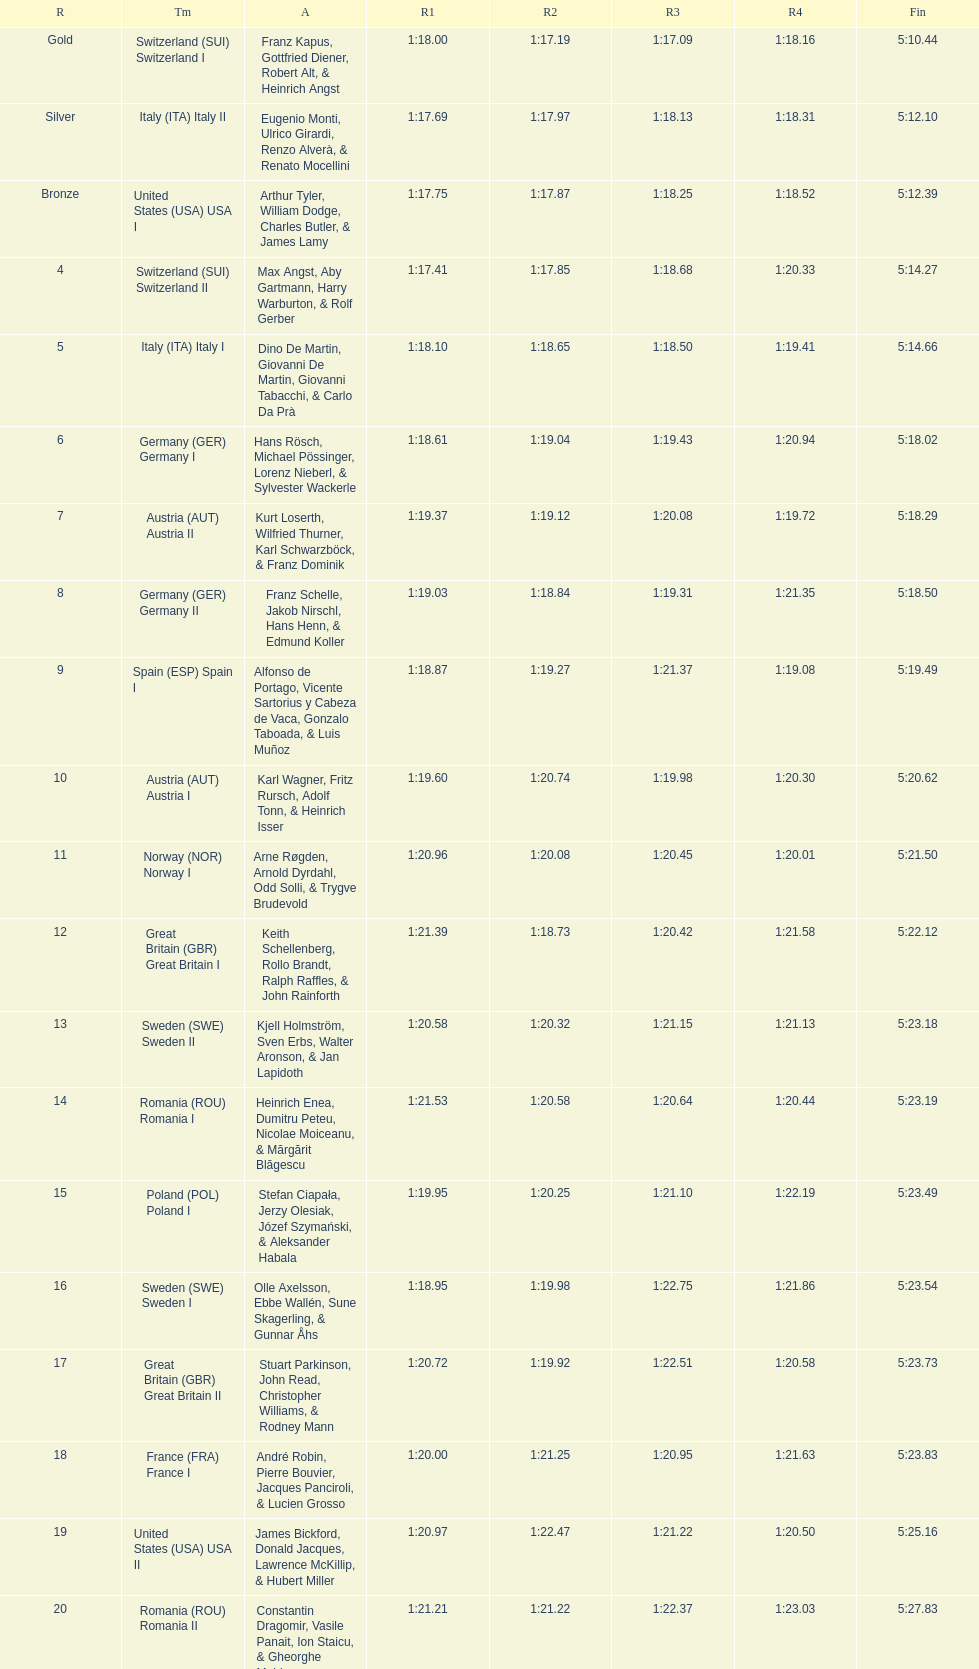What team came in second to last place? Romania. 